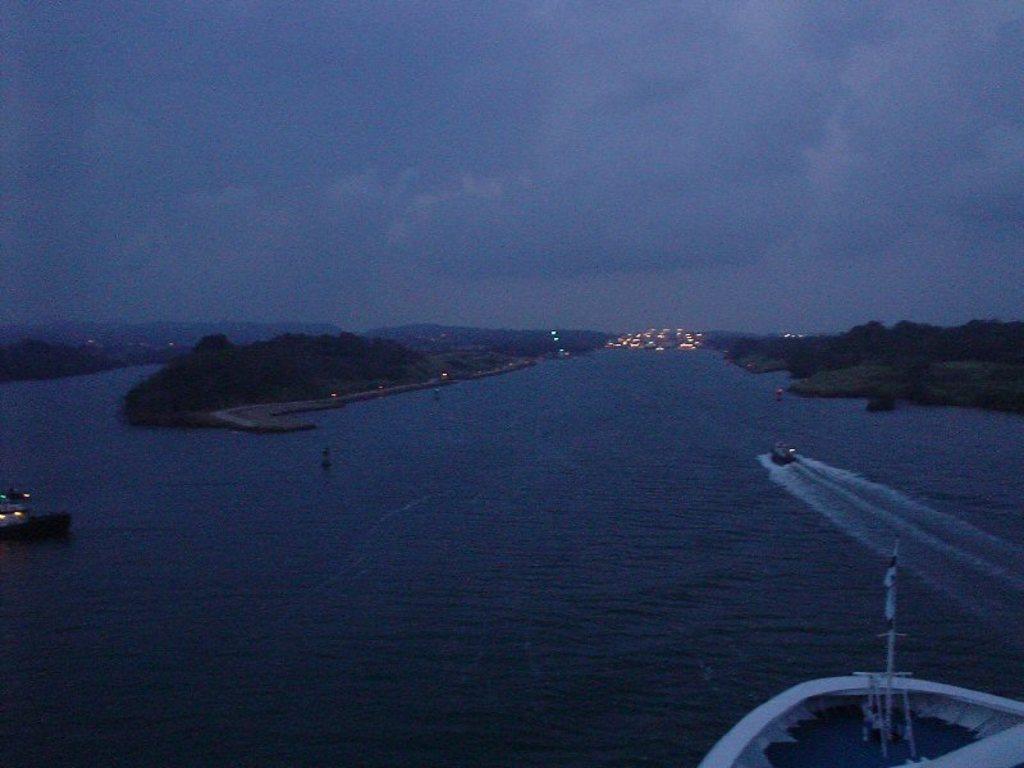How would you summarize this image in a sentence or two? In this image there is a sea in middle of this image and there are some trees at left side of this image and right side of this image as well. there are some ships and boats at right side of this image and left side of this image. There is a sky at top of this image. 